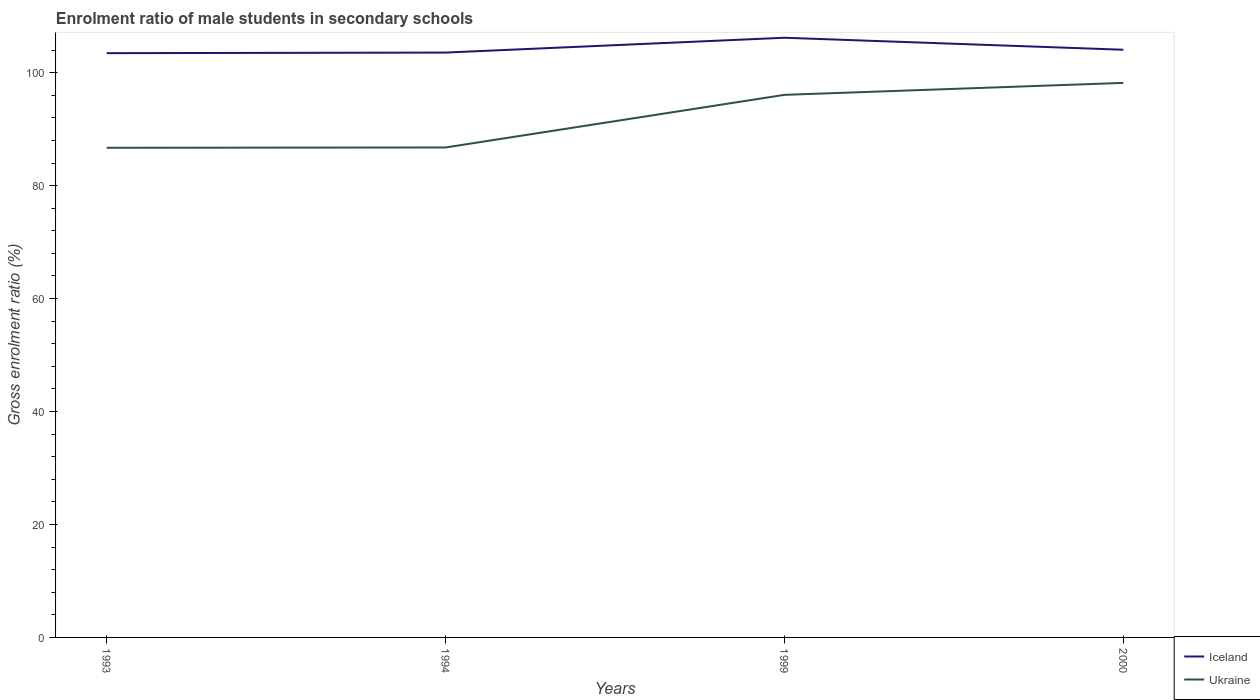How many different coloured lines are there?
Provide a succinct answer. 2. Does the line corresponding to Iceland intersect with the line corresponding to Ukraine?
Offer a terse response. No. Is the number of lines equal to the number of legend labels?
Keep it short and to the point. Yes. Across all years, what is the maximum enrolment ratio of male students in secondary schools in Iceland?
Give a very brief answer. 103.45. What is the total enrolment ratio of male students in secondary schools in Iceland in the graph?
Provide a succinct answer. -0.6. What is the difference between the highest and the second highest enrolment ratio of male students in secondary schools in Iceland?
Your answer should be very brief. 2.73. What is the difference between two consecutive major ticks on the Y-axis?
Offer a very short reply. 20. Are the values on the major ticks of Y-axis written in scientific E-notation?
Your response must be concise. No. How are the legend labels stacked?
Offer a terse response. Vertical. What is the title of the graph?
Ensure brevity in your answer.  Enrolment ratio of male students in secondary schools. What is the label or title of the Y-axis?
Your answer should be compact. Gross enrolment ratio (%). What is the Gross enrolment ratio (%) of Iceland in 1993?
Give a very brief answer. 103.45. What is the Gross enrolment ratio (%) in Ukraine in 1993?
Your answer should be very brief. 86.7. What is the Gross enrolment ratio (%) of Iceland in 1994?
Your answer should be very brief. 103.56. What is the Gross enrolment ratio (%) of Ukraine in 1994?
Give a very brief answer. 86.75. What is the Gross enrolment ratio (%) of Iceland in 1999?
Offer a terse response. 106.18. What is the Gross enrolment ratio (%) of Ukraine in 1999?
Provide a succinct answer. 96.07. What is the Gross enrolment ratio (%) in Iceland in 2000?
Keep it short and to the point. 104.06. What is the Gross enrolment ratio (%) in Ukraine in 2000?
Provide a succinct answer. 98.19. Across all years, what is the maximum Gross enrolment ratio (%) in Iceland?
Keep it short and to the point. 106.18. Across all years, what is the maximum Gross enrolment ratio (%) of Ukraine?
Ensure brevity in your answer.  98.19. Across all years, what is the minimum Gross enrolment ratio (%) of Iceland?
Your response must be concise. 103.45. Across all years, what is the minimum Gross enrolment ratio (%) in Ukraine?
Your response must be concise. 86.7. What is the total Gross enrolment ratio (%) in Iceland in the graph?
Ensure brevity in your answer.  417.25. What is the total Gross enrolment ratio (%) of Ukraine in the graph?
Your answer should be compact. 367.71. What is the difference between the Gross enrolment ratio (%) in Iceland in 1993 and that in 1994?
Give a very brief answer. -0.1. What is the difference between the Gross enrolment ratio (%) of Ukraine in 1993 and that in 1994?
Provide a succinct answer. -0.06. What is the difference between the Gross enrolment ratio (%) of Iceland in 1993 and that in 1999?
Offer a terse response. -2.73. What is the difference between the Gross enrolment ratio (%) of Ukraine in 1993 and that in 1999?
Make the answer very short. -9.37. What is the difference between the Gross enrolment ratio (%) of Iceland in 1993 and that in 2000?
Offer a terse response. -0.6. What is the difference between the Gross enrolment ratio (%) in Ukraine in 1993 and that in 2000?
Your response must be concise. -11.49. What is the difference between the Gross enrolment ratio (%) of Iceland in 1994 and that in 1999?
Offer a very short reply. -2.62. What is the difference between the Gross enrolment ratio (%) of Ukraine in 1994 and that in 1999?
Make the answer very short. -9.32. What is the difference between the Gross enrolment ratio (%) of Iceland in 1994 and that in 2000?
Provide a short and direct response. -0.5. What is the difference between the Gross enrolment ratio (%) of Ukraine in 1994 and that in 2000?
Your answer should be very brief. -11.43. What is the difference between the Gross enrolment ratio (%) of Iceland in 1999 and that in 2000?
Give a very brief answer. 2.12. What is the difference between the Gross enrolment ratio (%) of Ukraine in 1999 and that in 2000?
Provide a short and direct response. -2.12. What is the difference between the Gross enrolment ratio (%) of Iceland in 1993 and the Gross enrolment ratio (%) of Ukraine in 1994?
Ensure brevity in your answer.  16.7. What is the difference between the Gross enrolment ratio (%) of Iceland in 1993 and the Gross enrolment ratio (%) of Ukraine in 1999?
Give a very brief answer. 7.38. What is the difference between the Gross enrolment ratio (%) in Iceland in 1993 and the Gross enrolment ratio (%) in Ukraine in 2000?
Provide a succinct answer. 5.27. What is the difference between the Gross enrolment ratio (%) of Iceland in 1994 and the Gross enrolment ratio (%) of Ukraine in 1999?
Ensure brevity in your answer.  7.49. What is the difference between the Gross enrolment ratio (%) of Iceland in 1994 and the Gross enrolment ratio (%) of Ukraine in 2000?
Your response must be concise. 5.37. What is the difference between the Gross enrolment ratio (%) of Iceland in 1999 and the Gross enrolment ratio (%) of Ukraine in 2000?
Your response must be concise. 7.99. What is the average Gross enrolment ratio (%) of Iceland per year?
Your answer should be compact. 104.31. What is the average Gross enrolment ratio (%) in Ukraine per year?
Provide a short and direct response. 91.93. In the year 1993, what is the difference between the Gross enrolment ratio (%) in Iceland and Gross enrolment ratio (%) in Ukraine?
Make the answer very short. 16.76. In the year 1994, what is the difference between the Gross enrolment ratio (%) of Iceland and Gross enrolment ratio (%) of Ukraine?
Offer a very short reply. 16.8. In the year 1999, what is the difference between the Gross enrolment ratio (%) in Iceland and Gross enrolment ratio (%) in Ukraine?
Offer a terse response. 10.11. In the year 2000, what is the difference between the Gross enrolment ratio (%) of Iceland and Gross enrolment ratio (%) of Ukraine?
Provide a short and direct response. 5.87. What is the ratio of the Gross enrolment ratio (%) in Iceland in 1993 to that in 1994?
Offer a very short reply. 1. What is the ratio of the Gross enrolment ratio (%) in Iceland in 1993 to that in 1999?
Your answer should be very brief. 0.97. What is the ratio of the Gross enrolment ratio (%) of Ukraine in 1993 to that in 1999?
Give a very brief answer. 0.9. What is the ratio of the Gross enrolment ratio (%) of Ukraine in 1993 to that in 2000?
Your response must be concise. 0.88. What is the ratio of the Gross enrolment ratio (%) of Iceland in 1994 to that in 1999?
Give a very brief answer. 0.98. What is the ratio of the Gross enrolment ratio (%) of Ukraine in 1994 to that in 1999?
Provide a short and direct response. 0.9. What is the ratio of the Gross enrolment ratio (%) of Ukraine in 1994 to that in 2000?
Give a very brief answer. 0.88. What is the ratio of the Gross enrolment ratio (%) of Iceland in 1999 to that in 2000?
Your answer should be very brief. 1.02. What is the ratio of the Gross enrolment ratio (%) of Ukraine in 1999 to that in 2000?
Provide a short and direct response. 0.98. What is the difference between the highest and the second highest Gross enrolment ratio (%) of Iceland?
Offer a very short reply. 2.12. What is the difference between the highest and the second highest Gross enrolment ratio (%) of Ukraine?
Offer a terse response. 2.12. What is the difference between the highest and the lowest Gross enrolment ratio (%) of Iceland?
Your answer should be compact. 2.73. What is the difference between the highest and the lowest Gross enrolment ratio (%) of Ukraine?
Your answer should be compact. 11.49. 